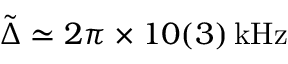<formula> <loc_0><loc_0><loc_500><loc_500>\tilde { \Delta } \simeq 2 \pi \times 1 0 ( 3 ) \, k H z</formula> 